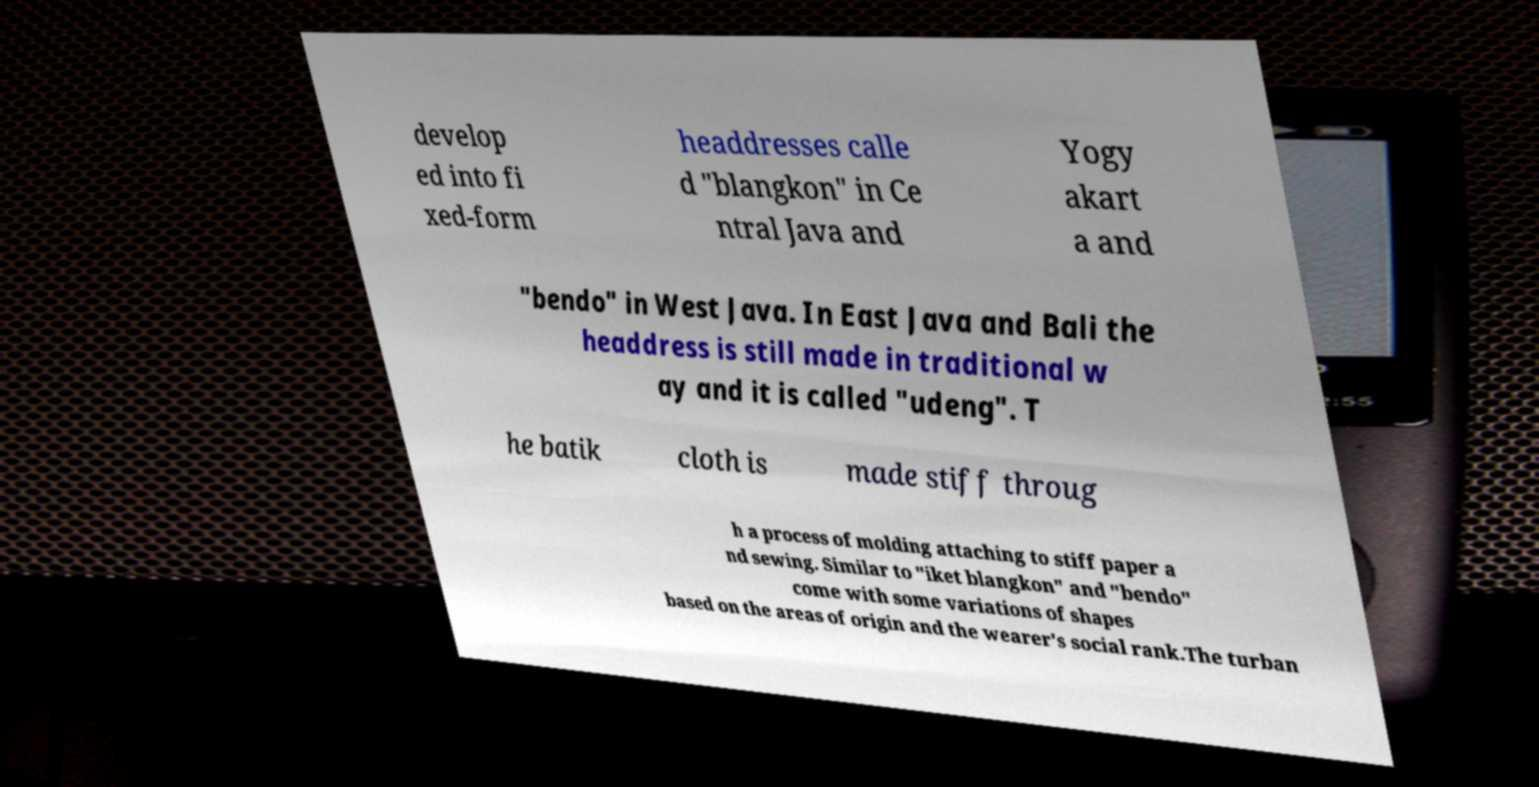Could you extract and type out the text from this image? develop ed into fi xed-form headdresses calle d "blangkon" in Ce ntral Java and Yogy akart a and "bendo" in West Java. In East Java and Bali the headdress is still made in traditional w ay and it is called "udeng". T he batik cloth is made stiff throug h a process of molding attaching to stiff paper a nd sewing. Similar to "iket blangkon" and "bendo" come with some variations of shapes based on the areas of origin and the wearer's social rank.The turban 